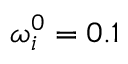<formula> <loc_0><loc_0><loc_500><loc_500>\omega _ { i } ^ { 0 } = 0 . 1</formula> 